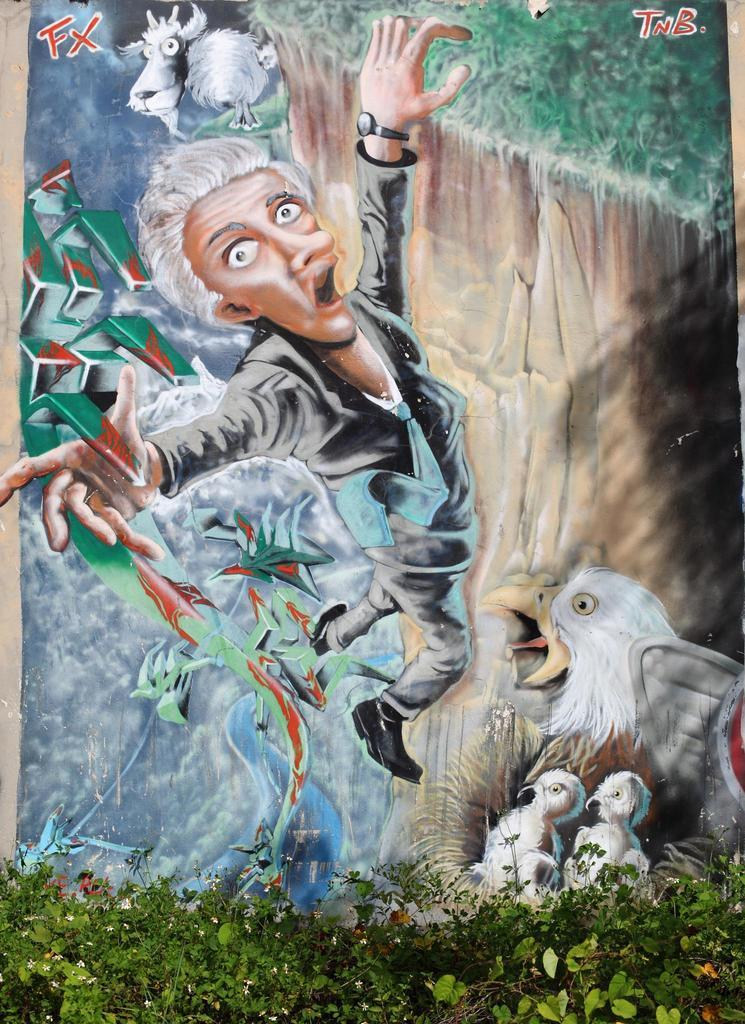What type of image is being described? The image is a cartoon. What is depicted in the cartoon? There is a cartoon picture of a person in the image. What animals can be seen in the image? There are birds in the middle of the image. What type of vegetation is at the bottom of the image? There are plants at the bottom of the image. How many balloons are being held by the person in the image? There are no balloons present in the image. What type of grass is visible in the image? There is no grass visible in the image. 